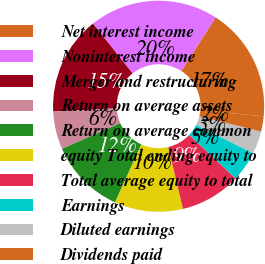Convert chart to OTSL. <chart><loc_0><loc_0><loc_500><loc_500><pie_chart><fcel>Net interest income<fcel>Noninterest income<fcel>Merger and restructuring<fcel>Return on average assets<fcel>Return on average common<fcel>equity Total ending equity to<fcel>Total average equity to total<fcel>Earnings<fcel>Diluted earnings<fcel>Dividends paid<nl><fcel>17.44%<fcel>19.77%<fcel>15.12%<fcel>5.81%<fcel>11.63%<fcel>10.47%<fcel>9.3%<fcel>4.65%<fcel>3.49%<fcel>2.33%<nl></chart> 